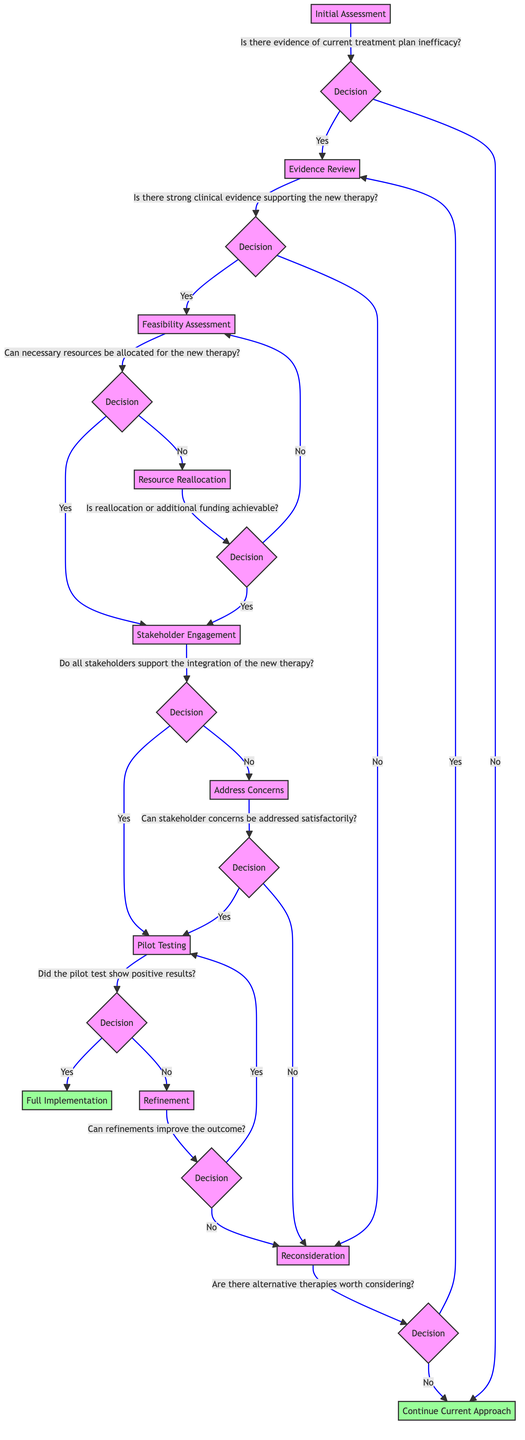What is the first step in the decision-making path? The first step in the diagram is the "Initial Assessment" node. It is the starting point from which all decisions flow.
Answer: Initial Assessment How many total decision nodes are present in the diagram? The diagram contains a total of eight decision nodes, including "Is there evidence of current treatment plan inefficacy?", "Is there strong clinical evidence supporting the new therapy?", among others.
Answer: Eight What happens if there is no strong clinical evidence supporting the new therapy? If there is no strong clinical evidence supporting the new therapy at the "Evidence Review," the path leads to "Reconsideration." This indicates that the evaluation process will have to revisit and explore alternative options.
Answer: Reconsideration What is the outcome if all stakeholders support the integration of the new therapy? If all stakeholders support the integration, the next step is "Pilot Testing." This suggests that the process moves forward to test the new approach in a controlled setting after securing stakeholder approval.
Answer: Pilot Testing What is the last step before Full Implementation? The last step before Full Implementation is "Pilot Testing," where the new therapeutic approach is tested to evaluate its effectiveness prior to full integration.
Answer: Pilot Testing If the pilot test does not show positive results, what is the next step? If the pilot test does not show positive results, the next step is "Refinement." This step requires adjustments to be made based on the feedback from the pilot test before attempting further action.
Answer: Refinement What leads to Resource Reallocation, and what is its purpose? Resource Reallocation is reached if necessary resources for the new therapy cannot be allocated during the "Feasibility Assessment." The purpose is to find additional funding or resources needed to support the new therapeutic approach.
Answer: Resource Reallocation If stakeholder concerns cannot be satisfactorily addressed, which step follows? If the concerns of the stakeholders cannot be satisfactorily addressed, the path leads back to "Reconsideration." This indicates a need to review the approach again and possibly consider alternatives.
Answer: Reconsideration 